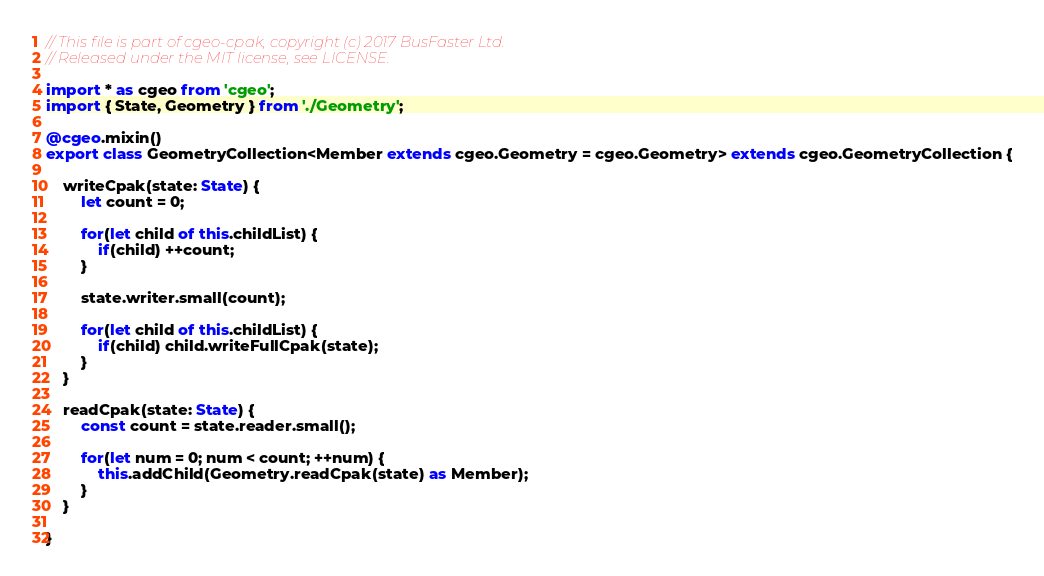Convert code to text. <code><loc_0><loc_0><loc_500><loc_500><_TypeScript_>// This file is part of cgeo-cpak, copyright (c) 2017 BusFaster Ltd.
// Released under the MIT license, see LICENSE.

import * as cgeo from 'cgeo';
import { State, Geometry } from './Geometry';

@cgeo.mixin()
export class GeometryCollection<Member extends cgeo.Geometry = cgeo.Geometry> extends cgeo.GeometryCollection {

	writeCpak(state: State) {
		let count = 0;

		for(let child of this.childList) {
			if(child) ++count;
		}

		state.writer.small(count);

		for(let child of this.childList) {
			if(child) child.writeFullCpak(state);
		}
	}

	readCpak(state: State) {
		const count = state.reader.small();

		for(let num = 0; num < count; ++num) {
			this.addChild(Geometry.readCpak(state) as Member);
		}
	}

}
</code> 